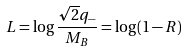Convert formula to latex. <formula><loc_0><loc_0><loc_500><loc_500>L = \log \frac { \sqrt { 2 } q _ { - } } { M _ { B } } = \log ( 1 - R )</formula> 